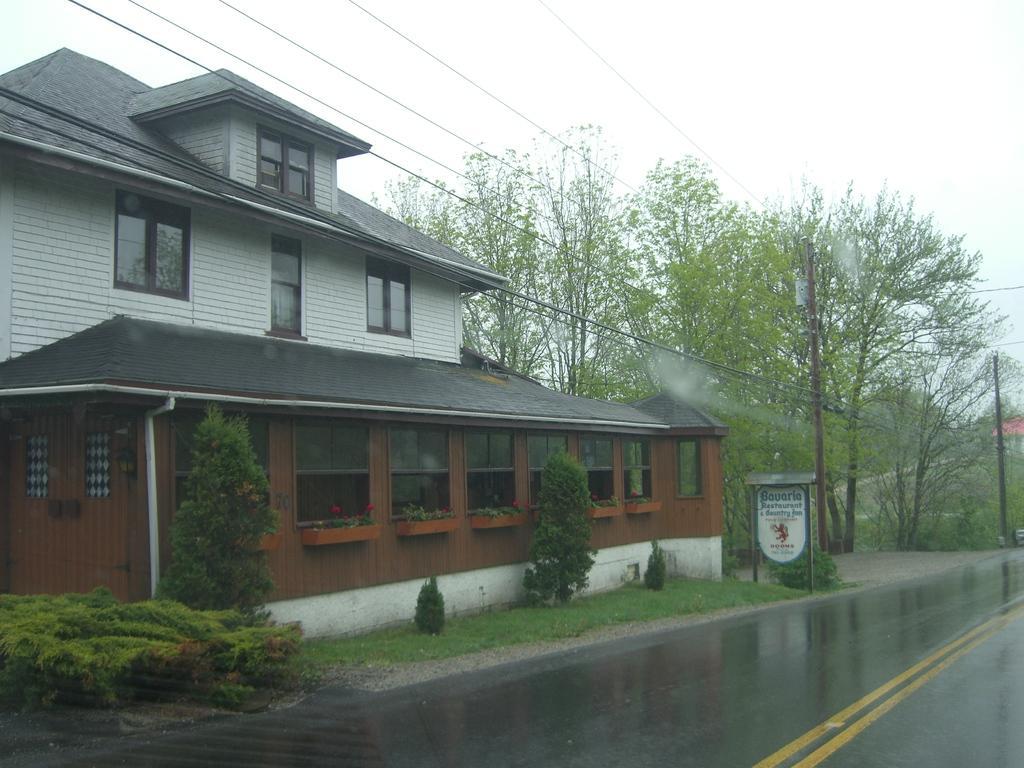Describe this image in one or two sentences. It is a house and there are many trees and grass around the house and beside the house there is a road,it is empty and wet. 